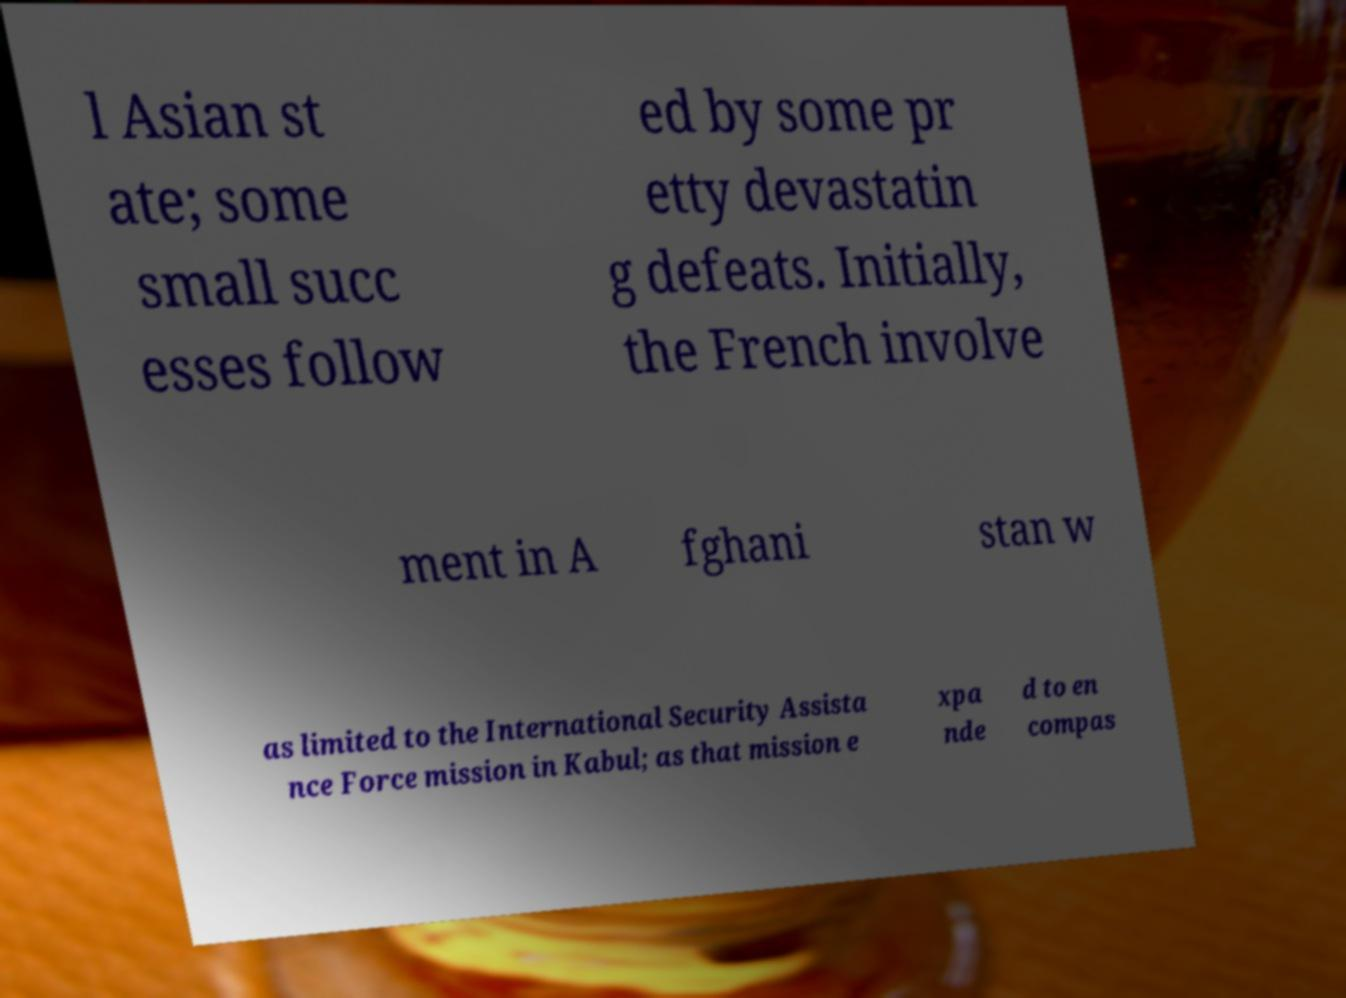Please read and relay the text visible in this image. What does it say? l Asian st ate; some small succ esses follow ed by some pr etty devastatin g defeats. Initially, the French involve ment in A fghani stan w as limited to the International Security Assista nce Force mission in Kabul; as that mission e xpa nde d to en compas 